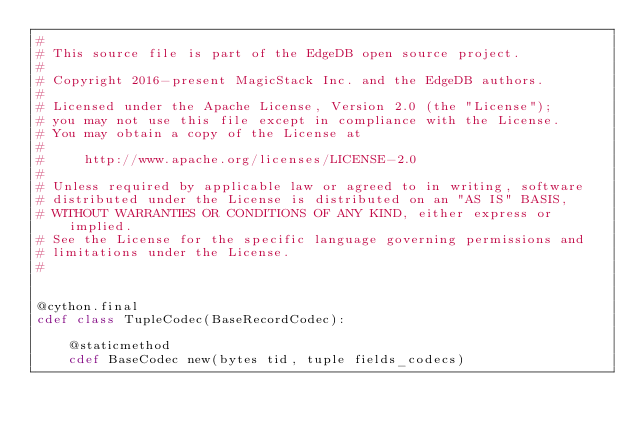<code> <loc_0><loc_0><loc_500><loc_500><_Cython_>#
# This source file is part of the EdgeDB open source project.
#
# Copyright 2016-present MagicStack Inc. and the EdgeDB authors.
#
# Licensed under the Apache License, Version 2.0 (the "License");
# you may not use this file except in compliance with the License.
# You may obtain a copy of the License at
#
#     http://www.apache.org/licenses/LICENSE-2.0
#
# Unless required by applicable law or agreed to in writing, software
# distributed under the License is distributed on an "AS IS" BASIS,
# WITHOUT WARRANTIES OR CONDITIONS OF ANY KIND, either express or implied.
# See the License for the specific language governing permissions and
# limitations under the License.
#


@cython.final
cdef class TupleCodec(BaseRecordCodec):

    @staticmethod
    cdef BaseCodec new(bytes tid, tuple fields_codecs)
</code> 